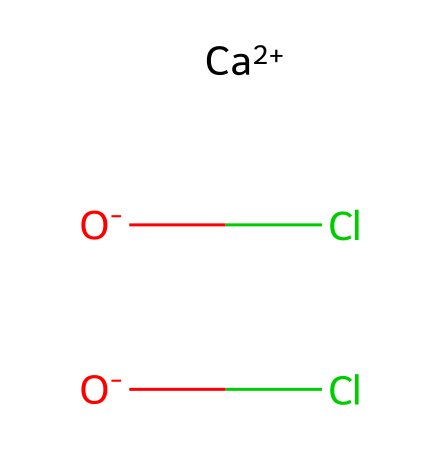What is the chemical name of the compound represented by this SMILES notation? The SMILES notation indicates that the chemical consists of calcium (Ca), two hypochlorite ions (ClO-). Thus, the compound name is derived from these components. The name is calcium hypochlorite.
Answer: calcium hypochlorite How many oxygen atoms are present in this chemical structure? By analyzing the structure, it is evident that there are two oxygen atoms in the hypochlorite groups (each ClO consists of one Cl and one O). Thus, we count two oxygen atoms.
Answer: two What type of chemical ions are present in the structural formula? The structural formula contains calcium ions and hypochlorite ions. Calcium is a cation (Ca+2) and hypochlorite is an anion (ClO-), showing both ionic components.
Answer: ions What is the oxidation state of chlorine in this compound? In hypochlorite (ClO-), chlorine typically exhibits a +1 oxidation state. This can be deduced from the charge of the hypochlorite ion and the known oxidation state of oxygen (-2).
Answer: +1 How does calcium hypochlorite function as an oxidizer? Calcium hypochlorite acts as an oxidizer because it can donate oxygen to react with other substances, causing oxidation. The presence of the hypochlorite ions facilitates the release of active oxygen, emphasizing its role as an oxidizing agent.
Answer: oxidizing agent 